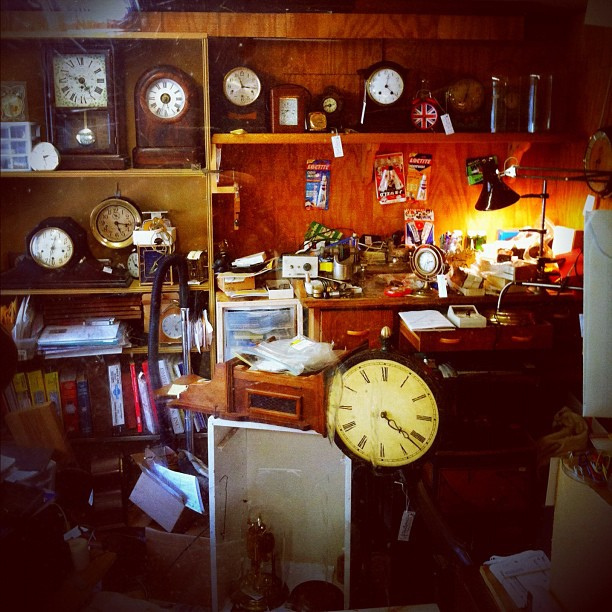<image>What is the picture in the bright yellow clock? I don't know what the picture in the bright yellow clock is. It seems there might not be a picture. What is the picture in the bright yellow clock? There is no picture in the bright yellow clock. 